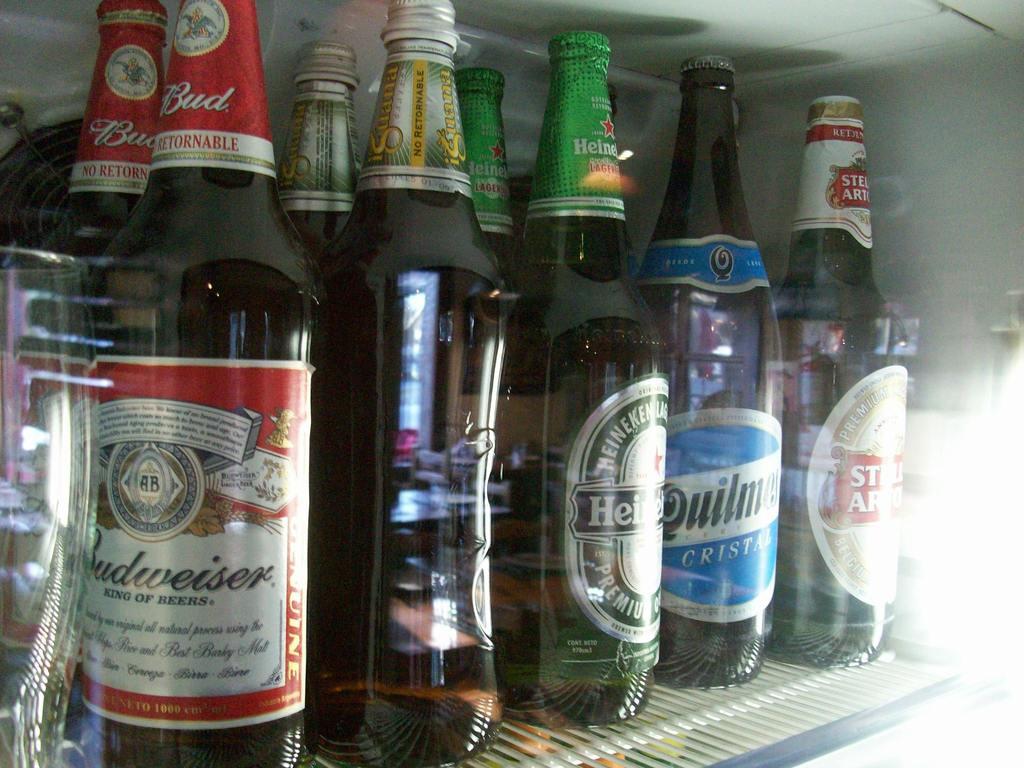What kinds of beers are in the fridge?
Provide a succinct answer. Budweiser. 